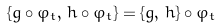Convert formula to latex. <formula><loc_0><loc_0><loc_500><loc_500>\{ g \circ \varphi _ { t } , \, h \circ \varphi _ { t } \} = \{ g , \, h \} \circ \varphi _ { t }</formula> 